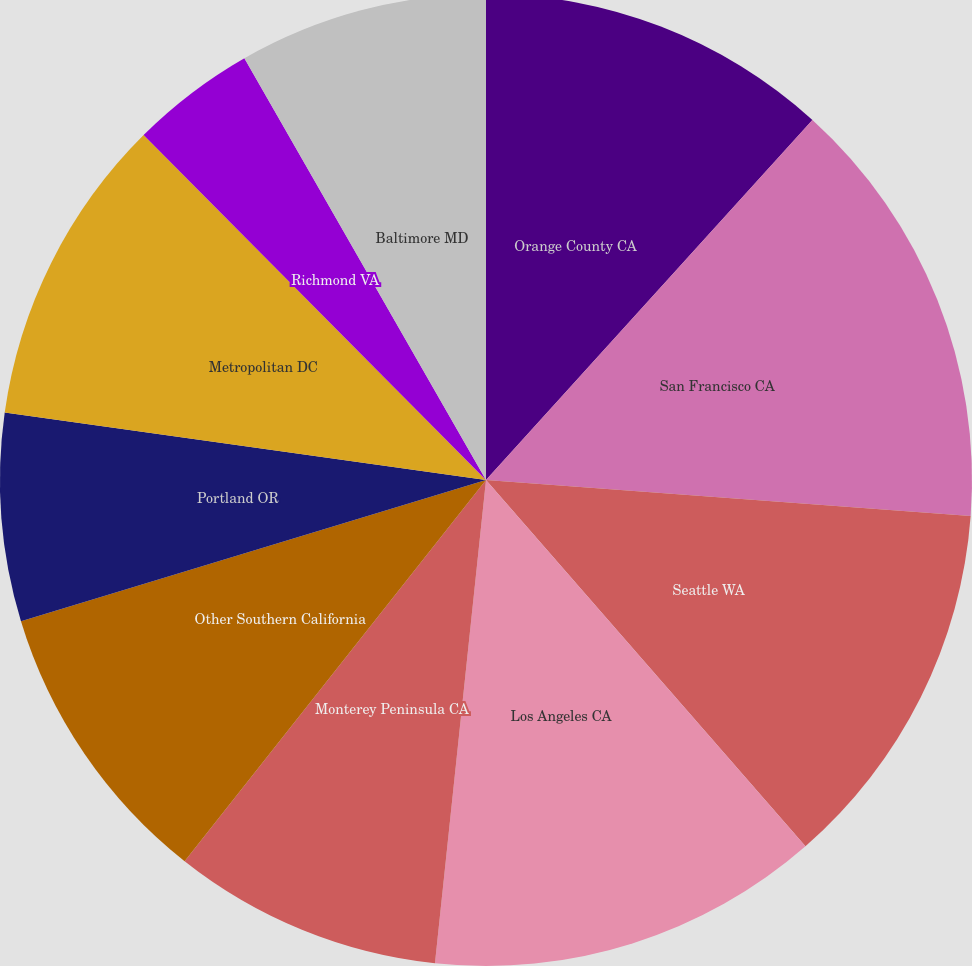Convert chart to OTSL. <chart><loc_0><loc_0><loc_500><loc_500><pie_chart><fcel>Orange County CA<fcel>San Francisco CA<fcel>Seattle WA<fcel>Los Angeles CA<fcel>Monterey Peninsula CA<fcel>Other Southern California<fcel>Portland OR<fcel>Metropolitan DC<fcel>Richmond VA<fcel>Baltimore MD<nl><fcel>11.72%<fcel>14.46%<fcel>12.4%<fcel>13.09%<fcel>8.97%<fcel>9.66%<fcel>6.91%<fcel>10.34%<fcel>4.16%<fcel>8.28%<nl></chart> 